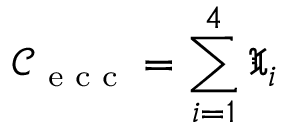<formula> <loc_0><loc_0><loc_500><loc_500>\mathcal { C } _ { e c c } = \sum _ { i = 1 } ^ { 4 } \mathfrak { X } _ { i }</formula> 